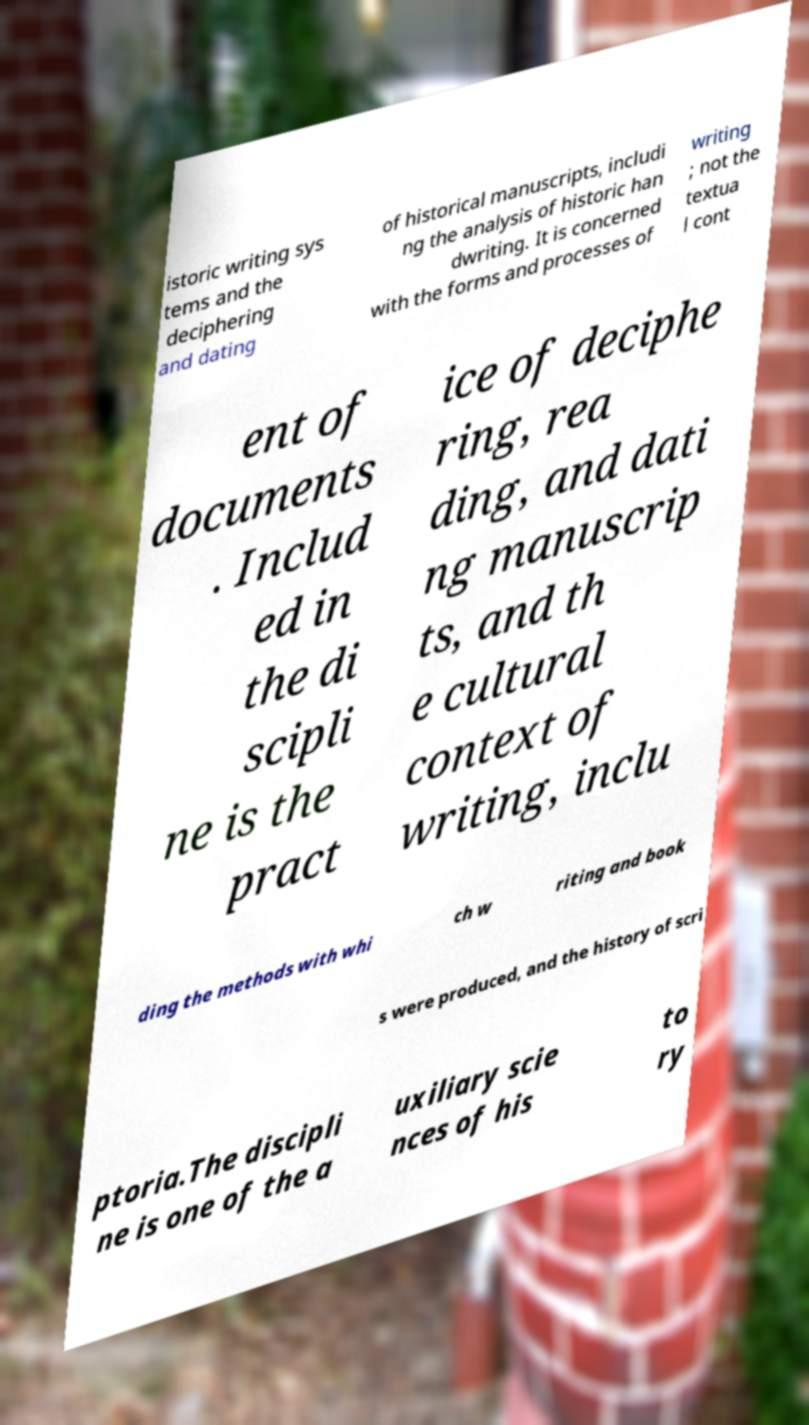Could you extract and type out the text from this image? istoric writing sys tems and the deciphering and dating of historical manuscripts, includi ng the analysis of historic han dwriting. It is concerned with the forms and processes of writing ; not the textua l cont ent of documents . Includ ed in the di scipli ne is the pract ice of deciphe ring, rea ding, and dati ng manuscrip ts, and th e cultural context of writing, inclu ding the methods with whi ch w riting and book s were produced, and the history of scri ptoria.The discipli ne is one of the a uxiliary scie nces of his to ry 